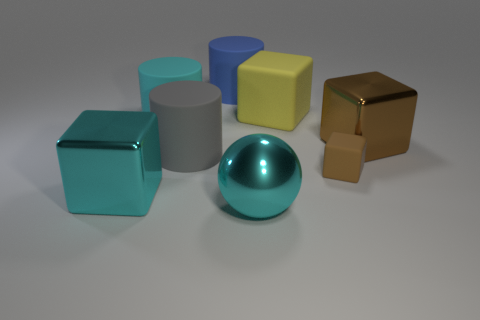What size is the yellow matte thing?
Ensure brevity in your answer.  Large. What is the tiny block made of?
Provide a succinct answer. Rubber. There is a cyan metallic object that is on the right side of the blue matte cylinder; does it have the same size as the large gray rubber thing?
Ensure brevity in your answer.  Yes. How many things are either large red cylinders or large metallic spheres?
Offer a terse response. 1. What is the shape of the big shiny thing that is the same color as the big ball?
Your response must be concise. Cube. There is a cube that is in front of the large brown shiny cube and behind the cyan cube; how big is it?
Give a very brief answer. Small. How many metal spheres are there?
Provide a succinct answer. 1. How many cubes are brown matte objects or cyan metallic objects?
Offer a very short reply. 2. What number of cyan metal things are in front of the big cube in front of the big block on the right side of the small brown rubber thing?
Give a very brief answer. 1. There is a matte cube that is the same size as the gray cylinder; what color is it?
Your answer should be compact. Yellow. 